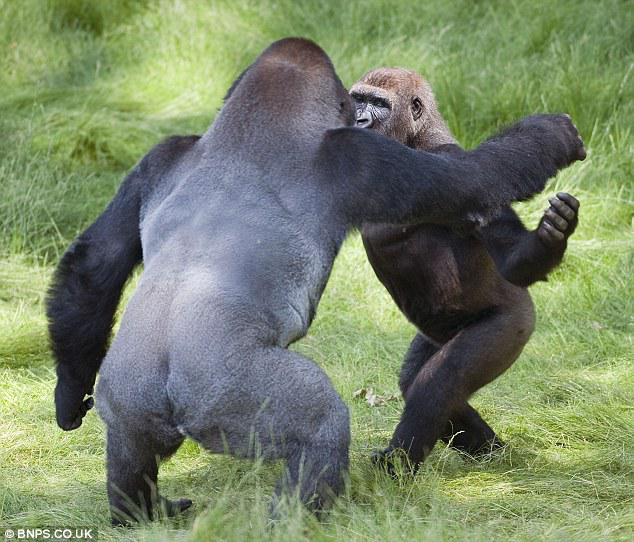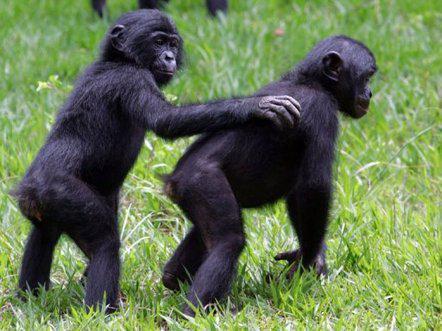The first image is the image on the left, the second image is the image on the right. Given the left and right images, does the statement "The left image shows a back-turned adult gorilla with a hump-shaped head standing upright and face-to-face with one other gorilla." hold true? Answer yes or no. Yes. The first image is the image on the left, the second image is the image on the right. Considering the images on both sides, is "There are more primates in the image on the right." valid? Answer yes or no. No. 